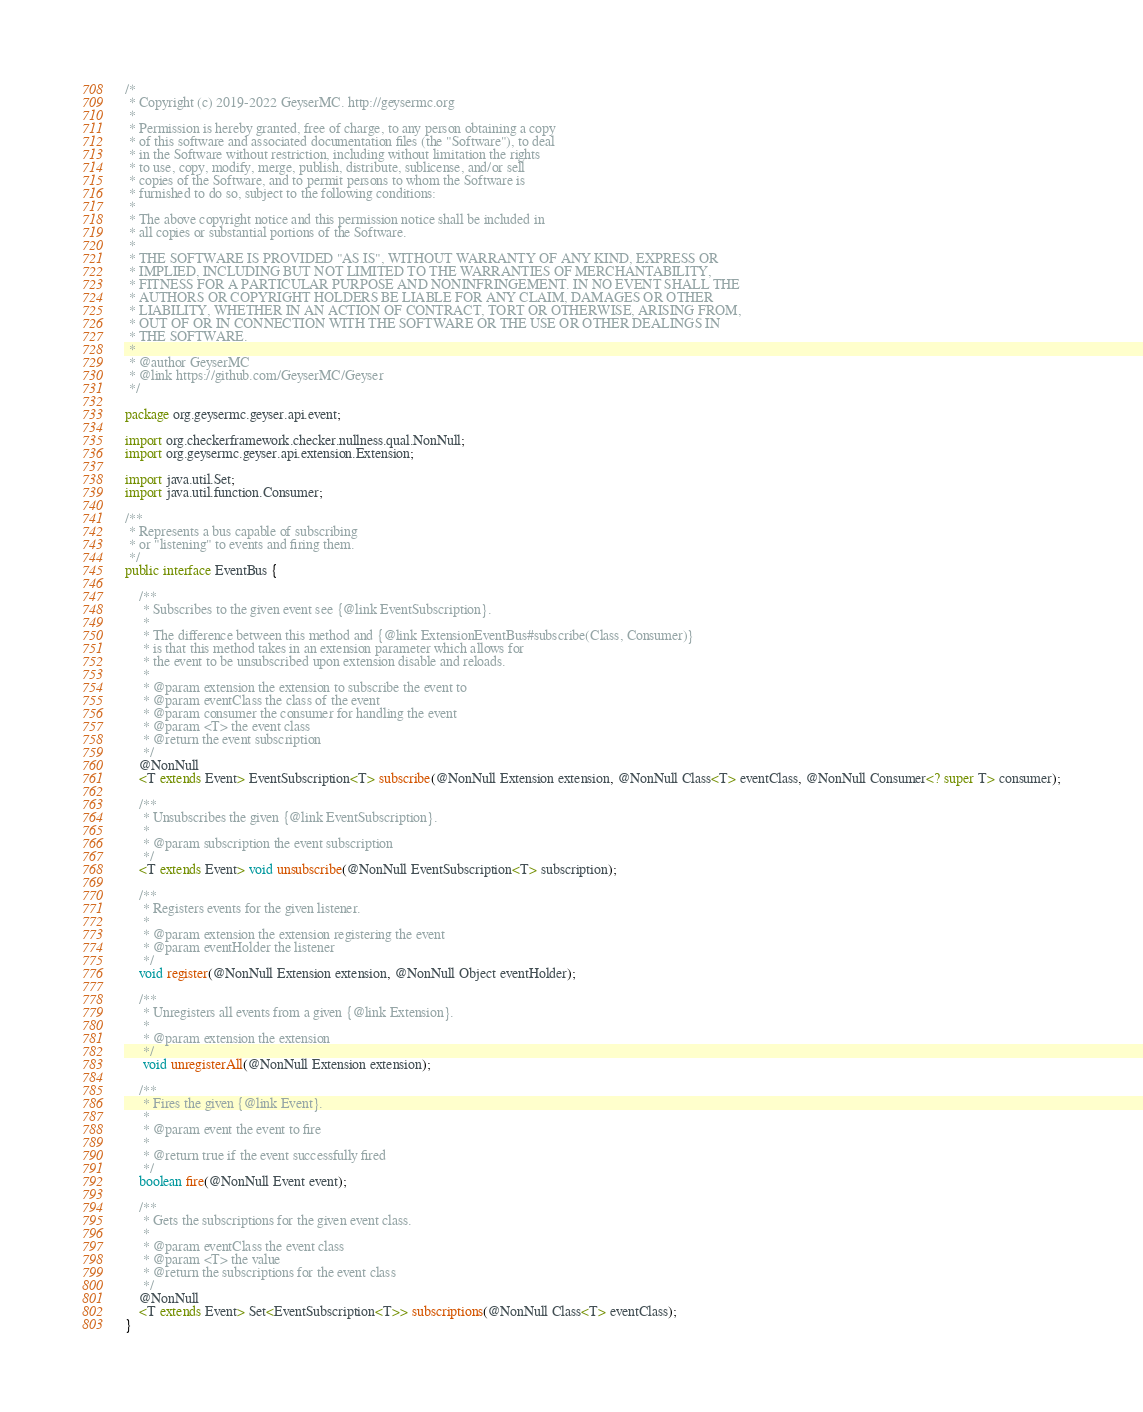Convert code to text. <code><loc_0><loc_0><loc_500><loc_500><_Java_>/*
 * Copyright (c) 2019-2022 GeyserMC. http://geysermc.org
 *
 * Permission is hereby granted, free of charge, to any person obtaining a copy
 * of this software and associated documentation files (the "Software"), to deal
 * in the Software without restriction, including without limitation the rights
 * to use, copy, modify, merge, publish, distribute, sublicense, and/or sell
 * copies of the Software, and to permit persons to whom the Software is
 * furnished to do so, subject to the following conditions:
 *
 * The above copyright notice and this permission notice shall be included in
 * all copies or substantial portions of the Software.
 *
 * THE SOFTWARE IS PROVIDED "AS IS", WITHOUT WARRANTY OF ANY KIND, EXPRESS OR
 * IMPLIED, INCLUDING BUT NOT LIMITED TO THE WARRANTIES OF MERCHANTABILITY,
 * FITNESS FOR A PARTICULAR PURPOSE AND NONINFRINGEMENT. IN NO EVENT SHALL THE
 * AUTHORS OR COPYRIGHT HOLDERS BE LIABLE FOR ANY CLAIM, DAMAGES OR OTHER
 * LIABILITY, WHETHER IN AN ACTION OF CONTRACT, TORT OR OTHERWISE, ARISING FROM,
 * OUT OF OR IN CONNECTION WITH THE SOFTWARE OR THE USE OR OTHER DEALINGS IN
 * THE SOFTWARE.
 *
 * @author GeyserMC
 * @link https://github.com/GeyserMC/Geyser
 */

package org.geysermc.geyser.api.event;

import org.checkerframework.checker.nullness.qual.NonNull;
import org.geysermc.geyser.api.extension.Extension;

import java.util.Set;
import java.util.function.Consumer;

/**
 * Represents a bus capable of subscribing
 * or "listening" to events and firing them.
 */
public interface EventBus {

    /**
     * Subscribes to the given event see {@link EventSubscription}.
     *
     * The difference between this method and {@link ExtensionEventBus#subscribe(Class, Consumer)}
     * is that this method takes in an extension parameter which allows for
     * the event to be unsubscribed upon extension disable and reloads.
     *
     * @param extension the extension to subscribe the event to
     * @param eventClass the class of the event
     * @param consumer the consumer for handling the event
     * @param <T> the event class
     * @return the event subscription
     */
    @NonNull
    <T extends Event> EventSubscription<T> subscribe(@NonNull Extension extension, @NonNull Class<T> eventClass, @NonNull Consumer<? super T> consumer);

    /**
     * Unsubscribes the given {@link EventSubscription}.
     *
     * @param subscription the event subscription
     */
    <T extends Event> void unsubscribe(@NonNull EventSubscription<T> subscription);

    /**
     * Registers events for the given listener.
     *
     * @param extension the extension registering the event
     * @param eventHolder the listener
     */
    void register(@NonNull Extension extension, @NonNull Object eventHolder);

    /**
     * Unregisters all events from a given {@link Extension}.
     *
     * @param extension the extension
     */
     void unregisterAll(@NonNull Extension extension);

    /**
     * Fires the given {@link Event}.
     *
     * @param event the event to fire
     *
     * @return true if the event successfully fired
     */
    boolean fire(@NonNull Event event);

    /**
     * Gets the subscriptions for the given event class.
     *
     * @param eventClass the event class
     * @param <T> the value
     * @return the subscriptions for the event class
     */
    @NonNull
    <T extends Event> Set<EventSubscription<T>> subscriptions(@NonNull Class<T> eventClass);
}
</code> 